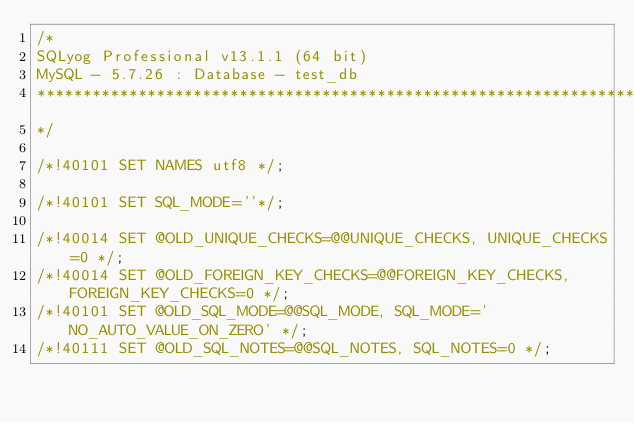<code> <loc_0><loc_0><loc_500><loc_500><_SQL_>/*
SQLyog Professional v13.1.1 (64 bit)
MySQL - 5.7.26 : Database - test_db
*********************************************************************
*/

/*!40101 SET NAMES utf8 */;

/*!40101 SET SQL_MODE=''*/;

/*!40014 SET @OLD_UNIQUE_CHECKS=@@UNIQUE_CHECKS, UNIQUE_CHECKS=0 */;
/*!40014 SET @OLD_FOREIGN_KEY_CHECKS=@@FOREIGN_KEY_CHECKS, FOREIGN_KEY_CHECKS=0 */;
/*!40101 SET @OLD_SQL_MODE=@@SQL_MODE, SQL_MODE='NO_AUTO_VALUE_ON_ZERO' */;
/*!40111 SET @OLD_SQL_NOTES=@@SQL_NOTES, SQL_NOTES=0 */;</code> 